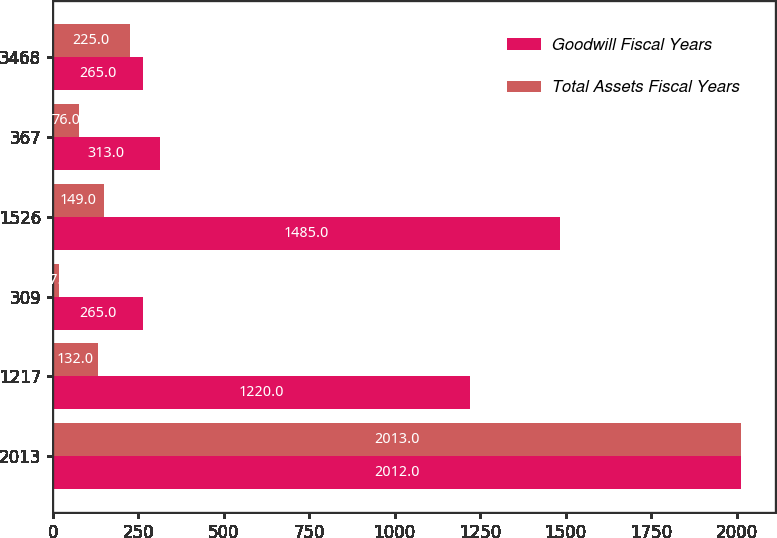Convert chart. <chart><loc_0><loc_0><loc_500><loc_500><stacked_bar_chart><ecel><fcel>2013<fcel>1217<fcel>309<fcel>1526<fcel>367<fcel>3468<nl><fcel>Goodwill Fiscal Years<fcel>2012<fcel>1220<fcel>265<fcel>1485<fcel>313<fcel>265<nl><fcel>Total Assets Fiscal Years<fcel>2013<fcel>132<fcel>17<fcel>149<fcel>76<fcel>225<nl></chart> 